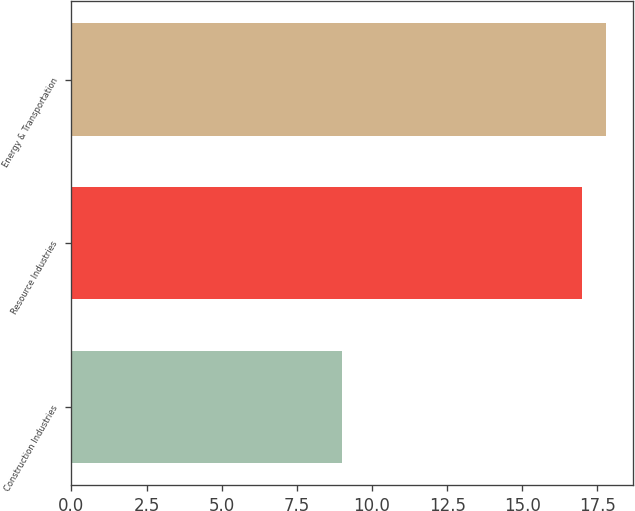Convert chart. <chart><loc_0><loc_0><loc_500><loc_500><bar_chart><fcel>Construction Industries<fcel>Resource Industries<fcel>Energy & Transportation<nl><fcel>9<fcel>17<fcel>17.8<nl></chart> 